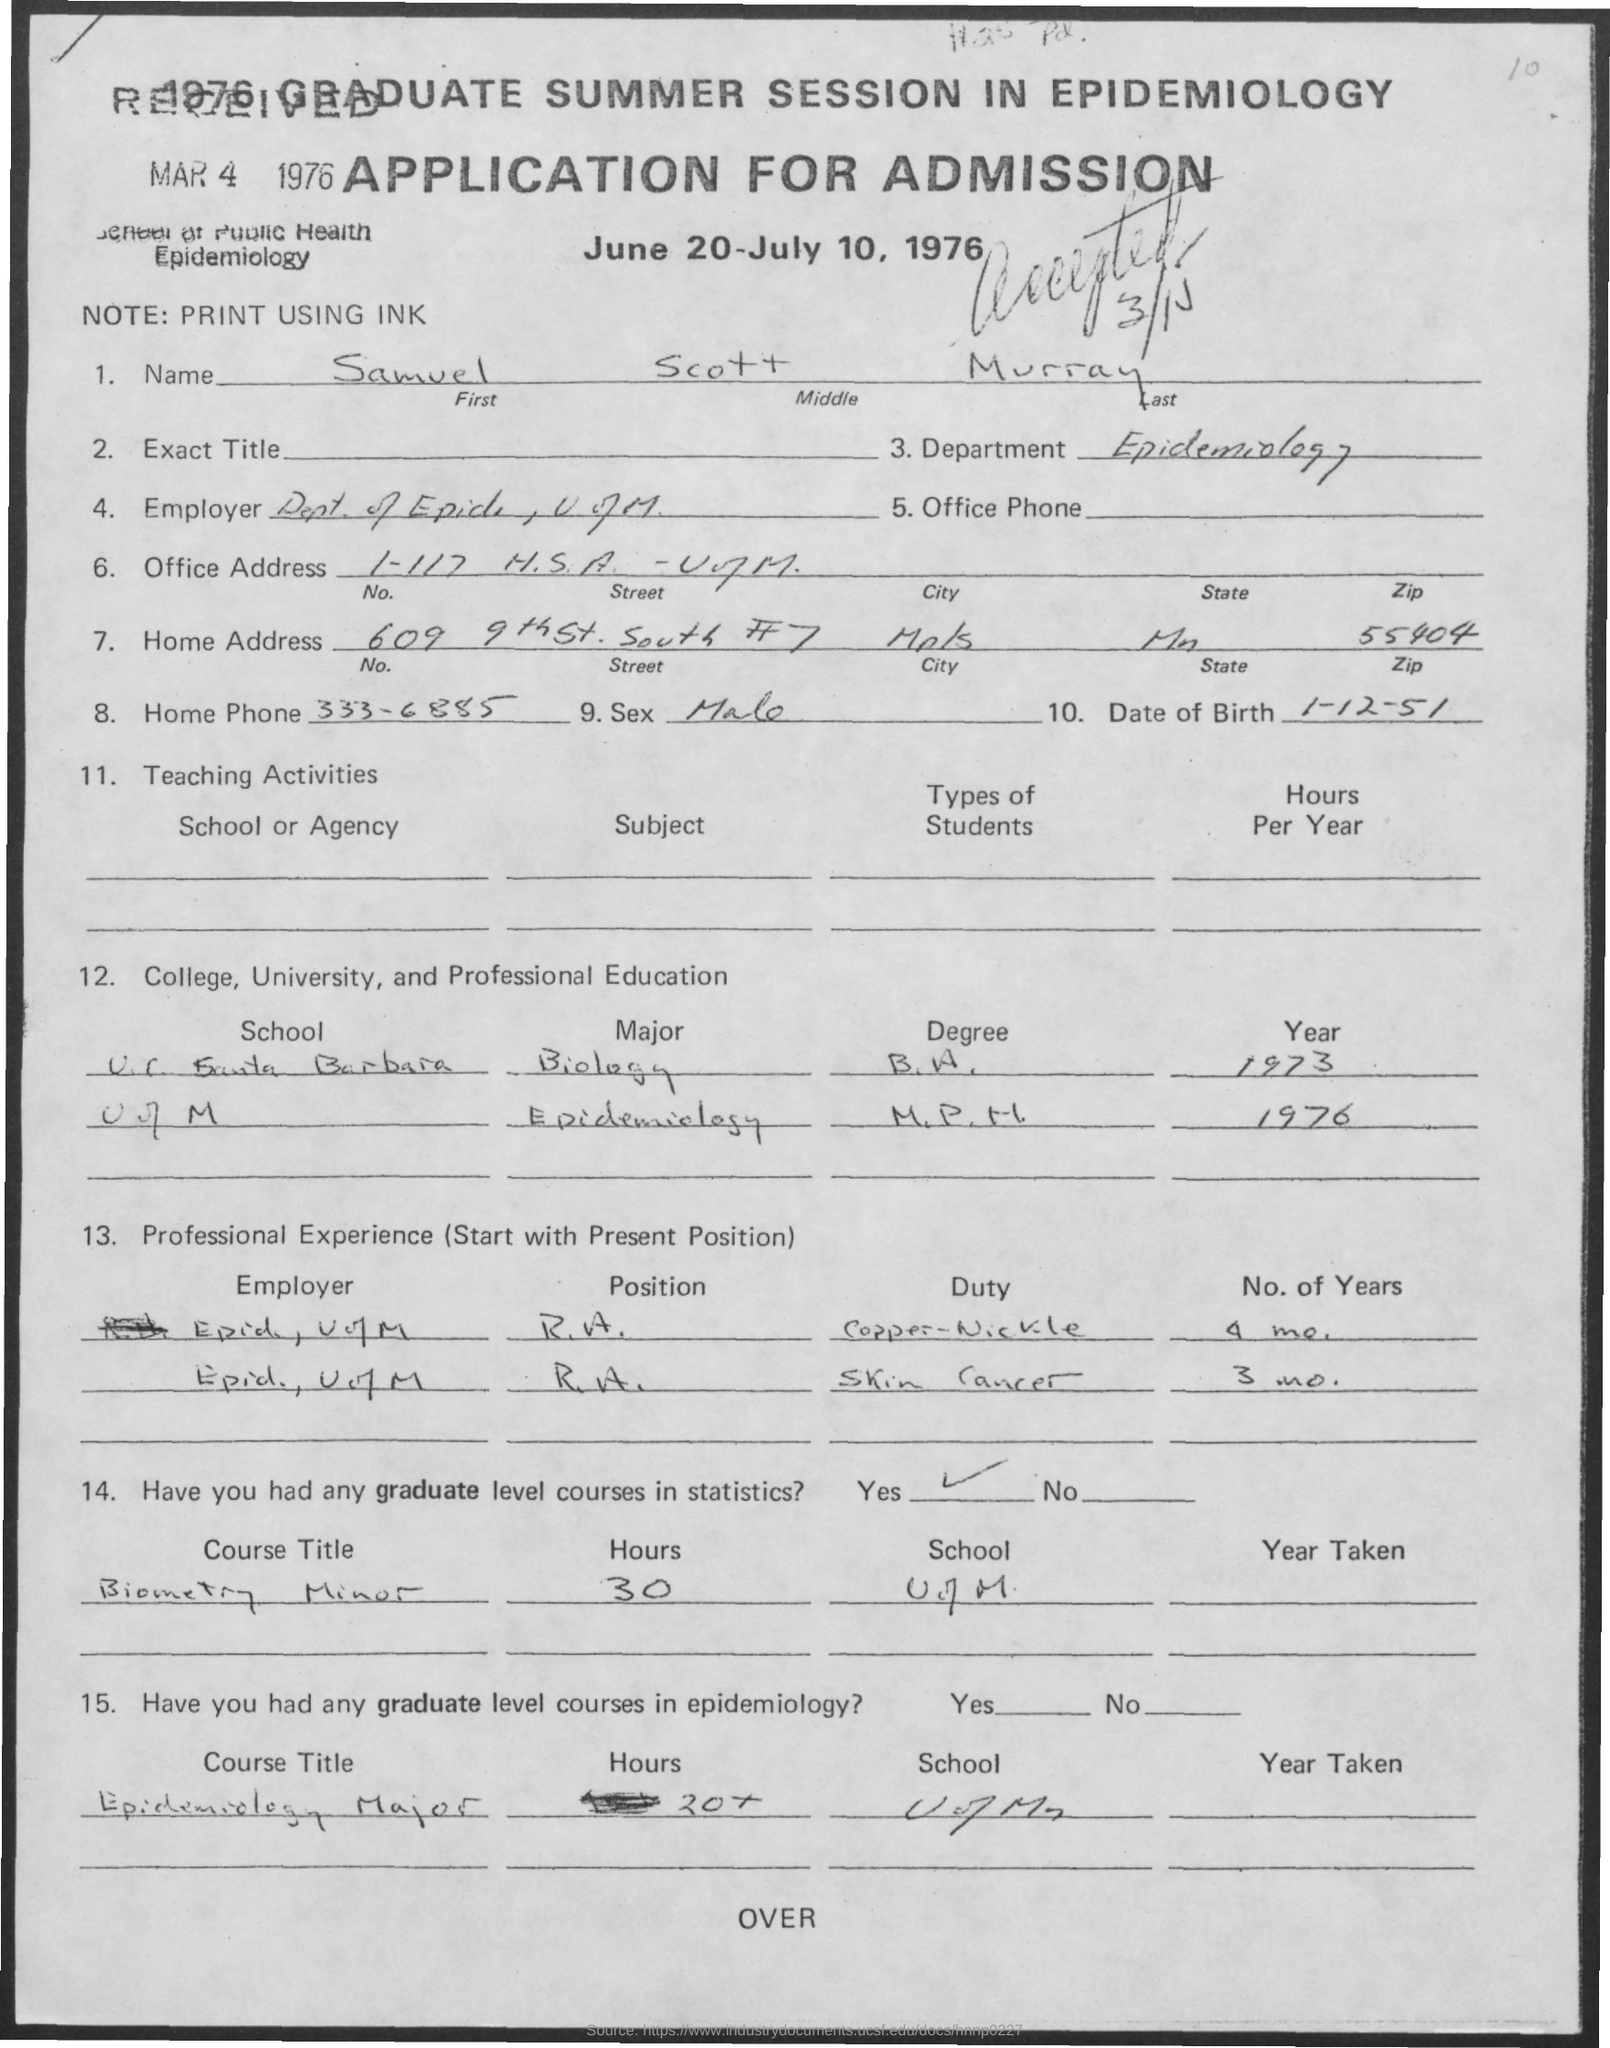What is the form?
Ensure brevity in your answer.  APPLICATION FOR ADMISSION. Name of person who applied?
Give a very brief answer. Samuel Scott Murray. How many year Samuel worked on Skin cancer?
Your answer should be very brief. 3 mo. Does Samuel have any Graduate level course in Statistics?
Provide a short and direct response. Yes. When Samuel was born?
Give a very brief answer. 1-12-51. How many hours were taken to finish epidemiology course?
Offer a terse response. 20+. 